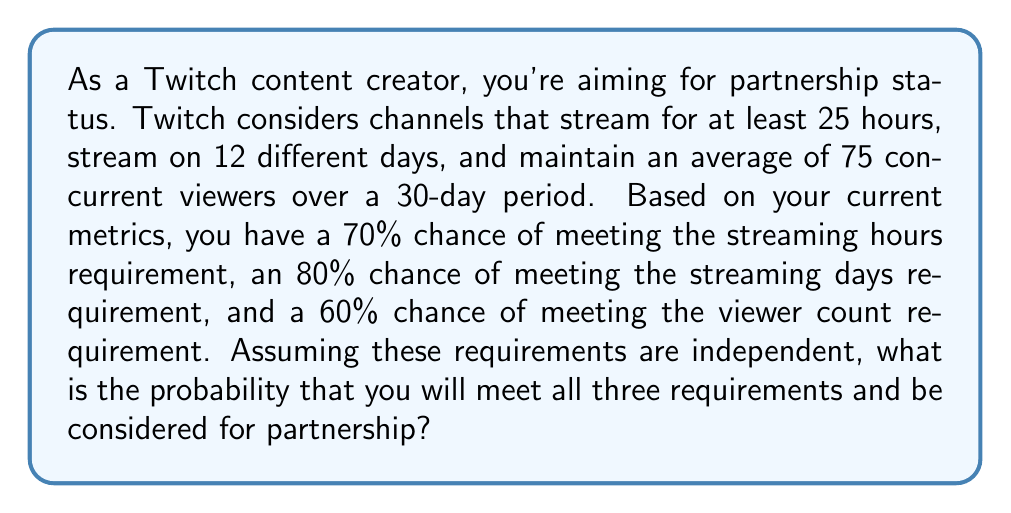Can you solve this math problem? To solve this problem, we need to use the multiplication rule of probability for independent events. Since we're assuming the requirements are independent, we can multiply the probabilities of meeting each requirement to find the probability of meeting all three.

Let's define our events:
$A$: Meeting the streaming hours requirement
$B$: Meeting the streaming days requirement
$C$: Meeting the viewer count requirement

We're given:
$P(A) = 0.70$
$P(B) = 0.80$
$P(C) = 0.60$

The probability of all three events occurring is:

$$P(A \cap B \cap C) = P(A) \times P(B) \times P(C)$$

Substituting our values:

$$P(A \cap B \cap C) = 0.70 \times 0.80 \times 0.60$$

Calculating:

$$P(A \cap B \cap C) = 0.336$$

Therefore, the probability of meeting all three requirements and being considered for partnership is 0.336 or 33.6%.
Answer: 0.336 or 33.6% 